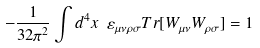Convert formula to latex. <formula><loc_0><loc_0><loc_500><loc_500>- \frac { 1 } { 3 2 \pi ^ { 2 } } \int d ^ { 4 } x \ \varepsilon _ { \mu \nu \rho \sigma } T r [ W _ { \mu \nu } W _ { \rho \sigma } ] = 1</formula> 